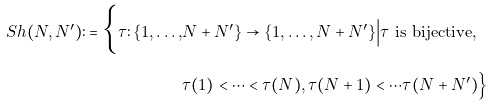Convert formula to latex. <formula><loc_0><loc_0><loc_500><loc_500>S h ( N , N ^ { \prime } ) \colon = \Big \{ \tau \colon \{ 1 , \dots , & N + N ^ { \prime } \} \to \{ 1 , \dots , N + N ^ { \prime } \} \Big | \tau \text { is bijective} , \\ & \tau ( 1 ) < \cdots < \tau ( N ) , \tau ( N + 1 ) < \cdots \tau ( N + N ^ { \prime } ) \Big \}</formula> 